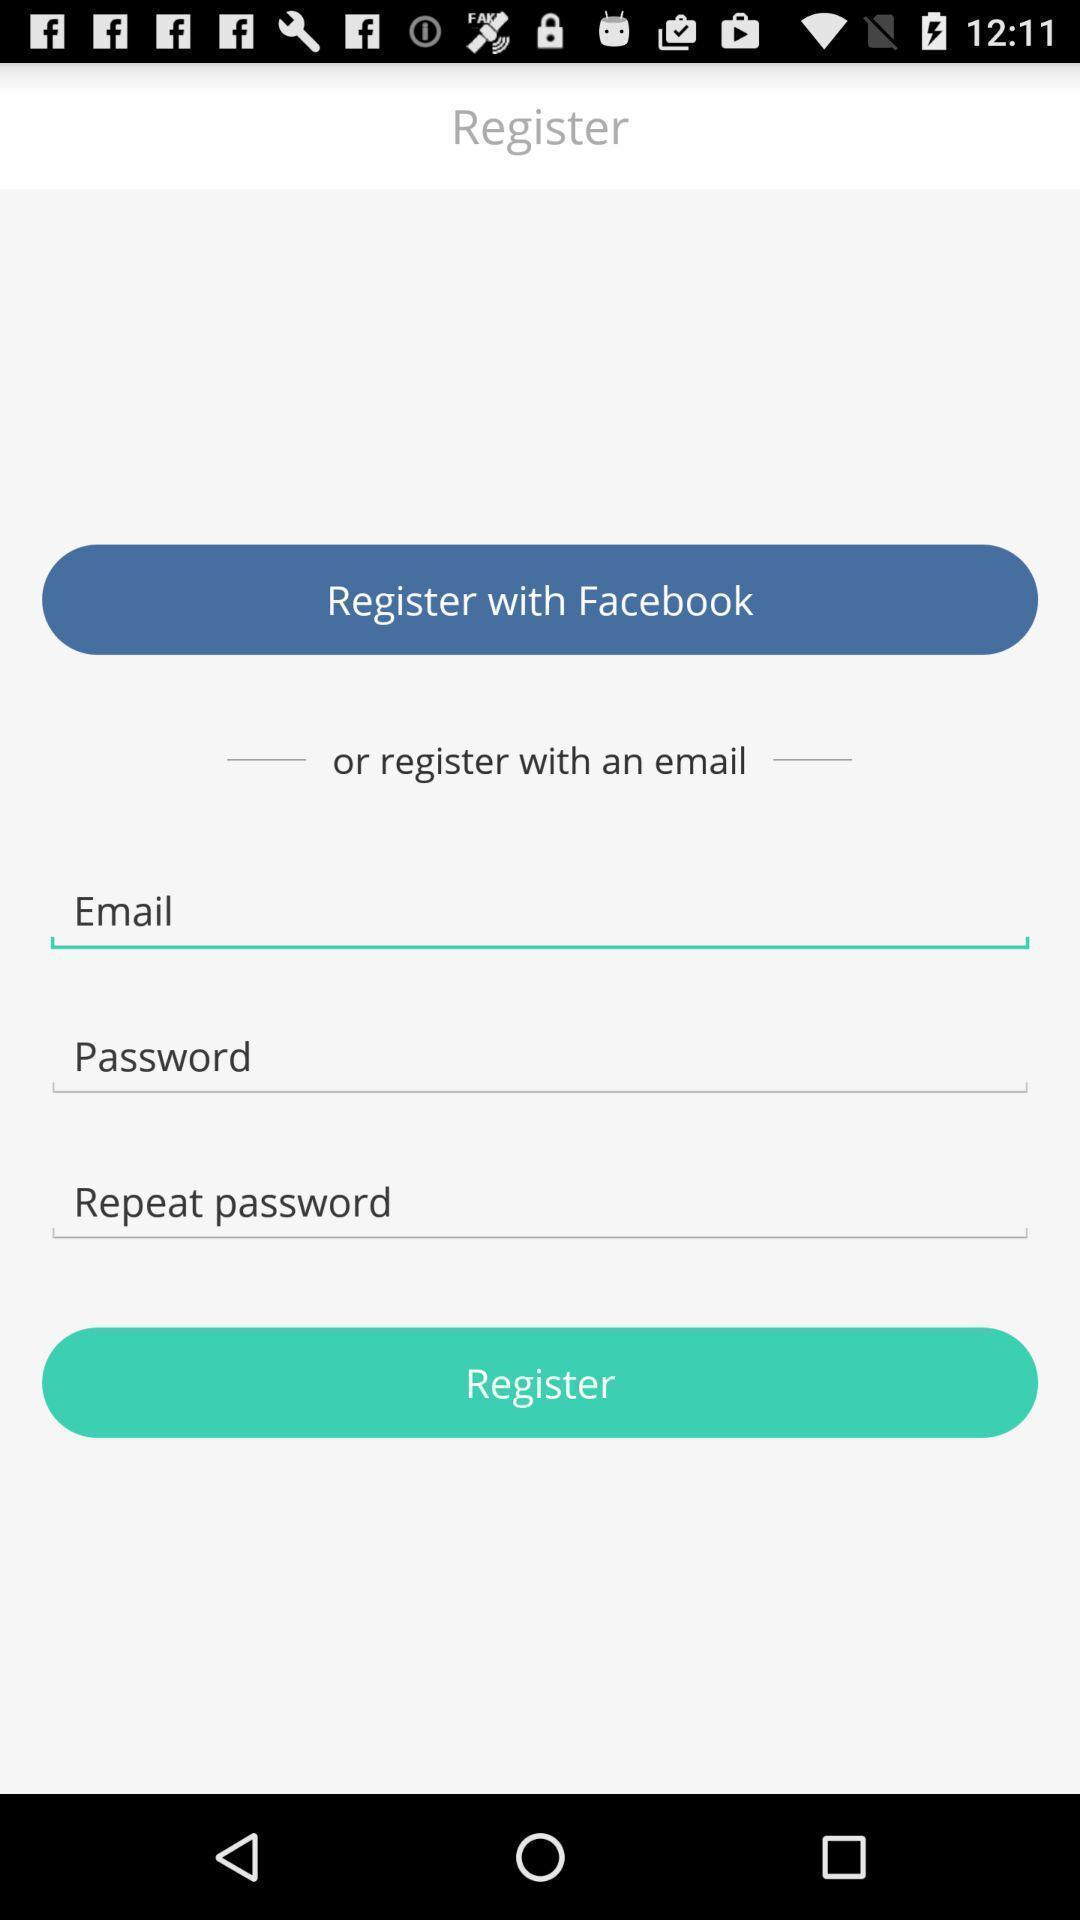Explain what's happening in this screen capture. Register page to enter details. 